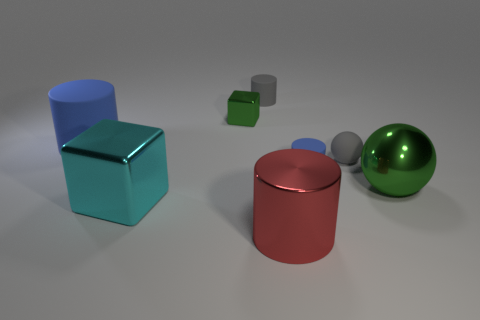Are there any large objects that have the same color as the small shiny object?
Make the answer very short. Yes. What is the size of the cylinder that is the same color as the rubber ball?
Offer a very short reply. Small. How many other objects are there of the same shape as the large green thing?
Offer a terse response. 1. Are there any blue cylinders that have the same material as the tiny sphere?
Your answer should be compact. Yes. Does the big thing behind the green metal ball have the same material as the green object in front of the small cube?
Provide a short and direct response. No. What number of shiny cubes are there?
Your answer should be very brief. 2. There is a thing that is in front of the large cube; what is its shape?
Ensure brevity in your answer.  Cylinder. How many other objects are there of the same size as the cyan shiny thing?
Keep it short and to the point. 3. There is a large object behind the tiny blue rubber cylinder; does it have the same shape as the blue thing right of the shiny cylinder?
Provide a succinct answer. Yes. There is a large red object; how many tiny things are to the left of it?
Keep it short and to the point. 2. 